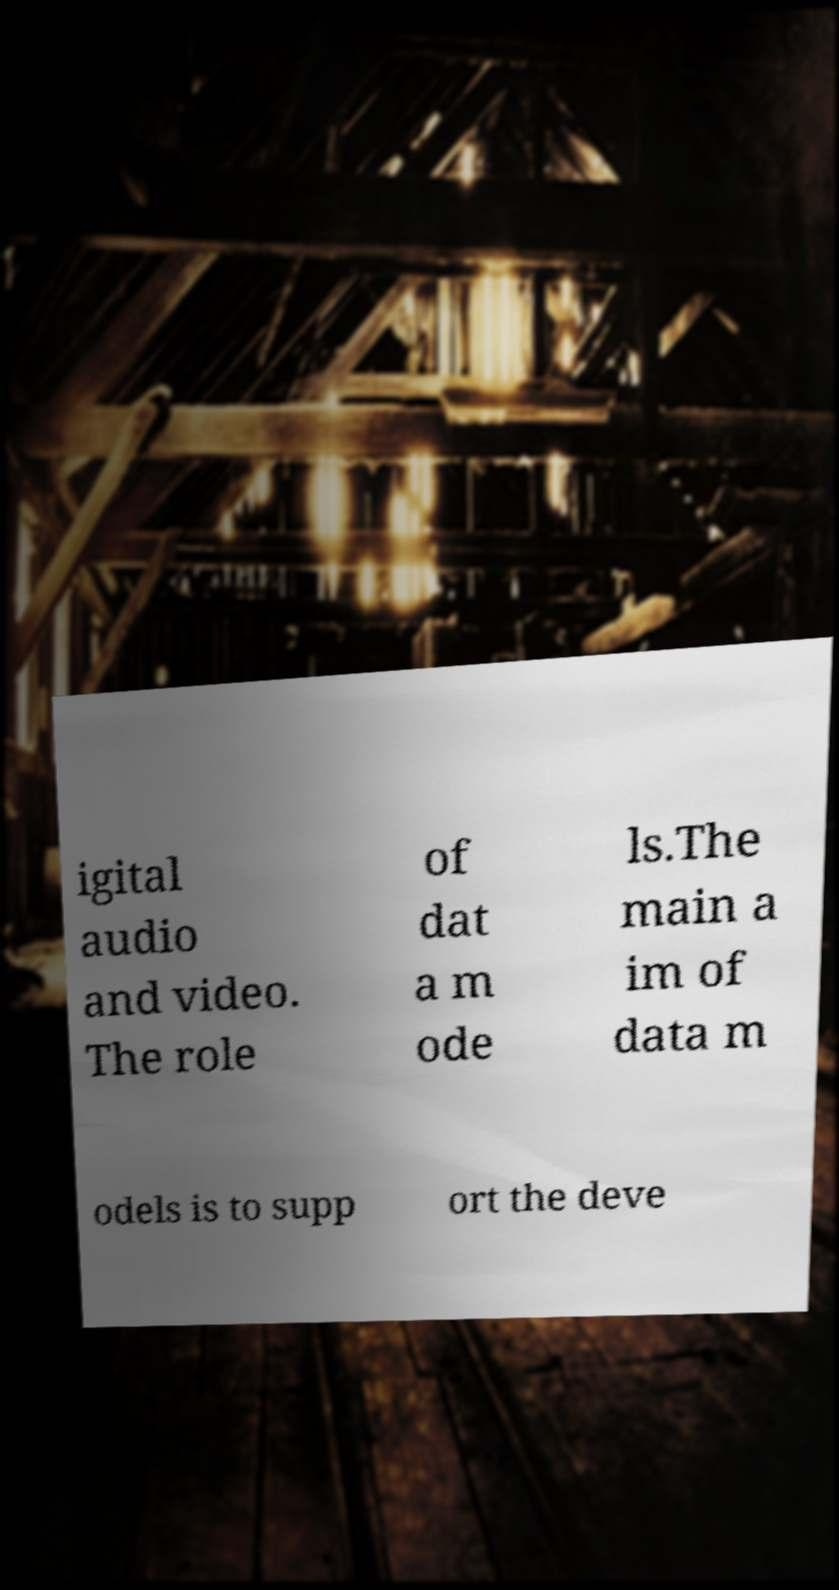Could you extract and type out the text from this image? igital audio and video. The role of dat a m ode ls.The main a im of data m odels is to supp ort the deve 